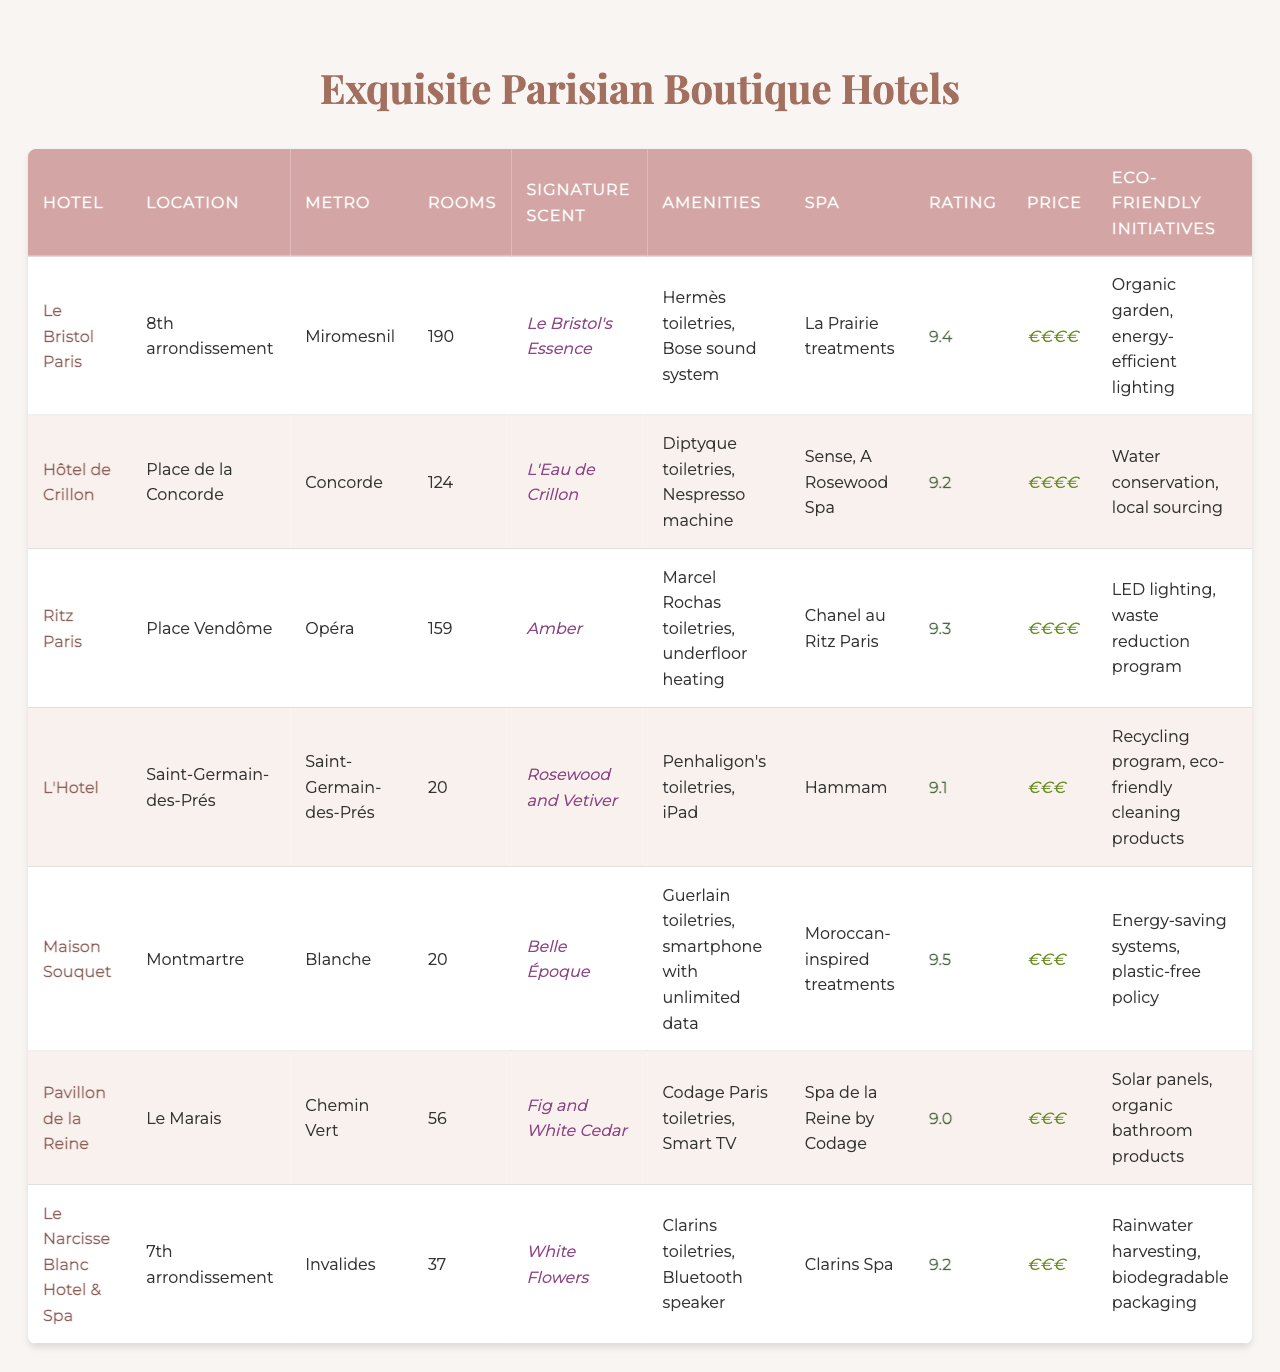What is the guest rating of Maison Souquet? According to the table, the guest rating for Maison Souquet is listed as 9.5.
Answer: 9.5 What aroma signifies Le Bristol Paris? The signature scent for Le Bristol Paris is "Le Bristol's Essence," as indicated in the table.
Answer: Le Bristol's Essence Which hotel has the fewest number of rooms? The table shows that L'Hotel and Maison Souquet each have 20 rooms, making them the hotels with the fewest rooms.
Answer: L'Hotel and Maison Souquet What is the price range for the hotels located in the 8th arrondissement? Le Bristol Paris, located in the 8th arrondissement, has a price range of €€€€.
Answer: €€€€ Does Hôtel de Crillon offer any eco-friendly initiatives? Yes, Hôtel de Crillon implements water conservation and local sourcing, according to the table.
Answer: Yes Which hotel provides in-room amenities that include a smartphone with unlimited data? As per the data, Maison Souquet provides in-room amenities that include a smartphone with unlimited data.
Answer: Maison Souquet What is the average guest rating of all the listed hotels? The guest ratings are: 9.4, 9.2, 9.3, 9.1, 9.5, 9.0, 9.2. The average is calculated by adding them up (9.4 + 9.2 + 9.3 + 9.1 + 9.5 + 9.0 + 9.2 = 65.7) and dividing by 7, which gives an average guest rating of 9.385714286.
Answer: 9.39 Which hotel among the listed has a Moroccan-inspired spa service? The table indicates that Maison Souquet offers Moroccan-inspired spa services.
Answer: Maison Souquet How many hotels have the same rating as the Ritz Paris? The Ritz Paris has a rating of 9.3. Upon checking the other hotels, it appears that only one other hotel, Hôtel de Crillon, shares this rating.
Answer: 1 Is there a hotel location in Montmartre with an eco-friendly initiative? Yes, Maison Souquet is located in Montmartre and implements energy-saving systems and a plastic-free policy as eco-friendly initiatives.
Answer: Yes Which hotel has more rooms, L'Hotel or Pavillon de la Reine? L'Hotel has 20 rooms and Pavillon de la Reine has 56 rooms. Therefore, Pavillon de la Reine has more rooms than L'Hotel.
Answer: Pavillon de la Reine 